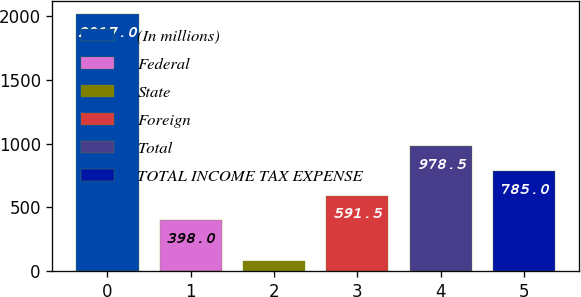Convert chart. <chart><loc_0><loc_0><loc_500><loc_500><bar_chart><fcel>(In millions)<fcel>Federal<fcel>State<fcel>Foreign<fcel>Total<fcel>TOTAL INCOME TAX EXPENSE<nl><fcel>2017<fcel>398<fcel>82<fcel>591.5<fcel>978.5<fcel>785<nl></chart> 